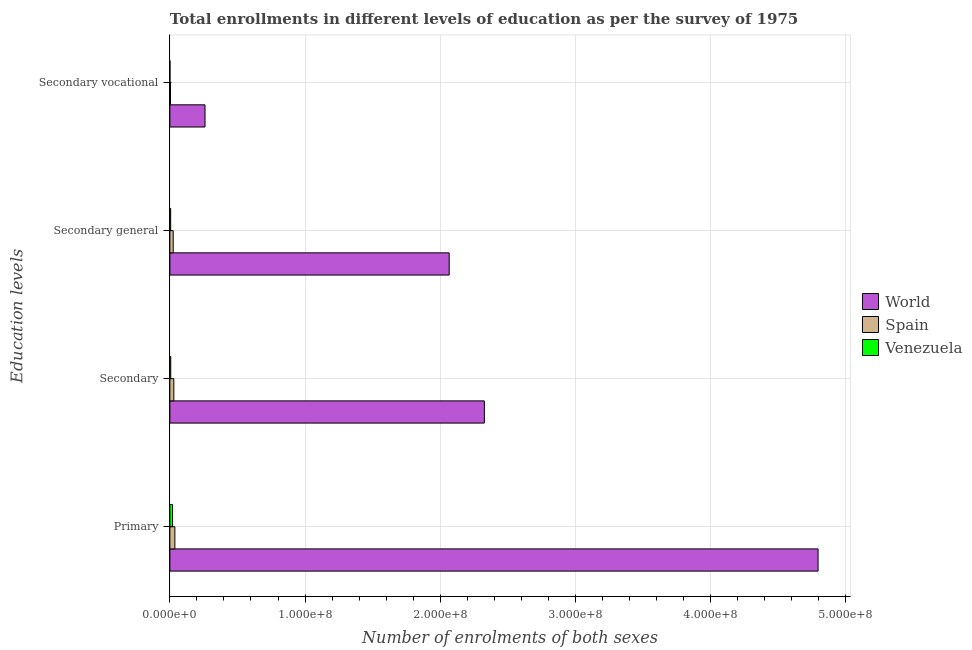How many different coloured bars are there?
Ensure brevity in your answer.  3. Are the number of bars per tick equal to the number of legend labels?
Keep it short and to the point. Yes. How many bars are there on the 3rd tick from the top?
Ensure brevity in your answer.  3. How many bars are there on the 1st tick from the bottom?
Provide a short and direct response. 3. What is the label of the 4th group of bars from the top?
Offer a very short reply. Primary. What is the number of enrolments in secondary general education in Venezuela?
Keep it short and to the point. 5.83e+05. Across all countries, what is the maximum number of enrolments in secondary vocational education?
Make the answer very short. 2.60e+07. Across all countries, what is the minimum number of enrolments in secondary education?
Offer a very short reply. 6.31e+05. In which country was the number of enrolments in primary education maximum?
Your answer should be very brief. World. In which country was the number of enrolments in secondary general education minimum?
Keep it short and to the point. Venezuela. What is the total number of enrolments in secondary vocational education in the graph?
Offer a very short reply. 2.65e+07. What is the difference between the number of enrolments in secondary vocational education in Venezuela and that in Spain?
Offer a terse response. -4.09e+05. What is the difference between the number of enrolments in secondary general education in Spain and the number of enrolments in secondary education in Venezuela?
Give a very brief answer. 1.83e+06. What is the average number of enrolments in secondary general education per country?
Provide a short and direct response. 6.99e+07. What is the difference between the number of enrolments in secondary vocational education and number of enrolments in secondary education in Spain?
Offer a terse response. -2.46e+06. What is the ratio of the number of enrolments in primary education in World to that in Spain?
Your answer should be very brief. 129.85. Is the difference between the number of enrolments in secondary education in Spain and Venezuela greater than the difference between the number of enrolments in secondary vocational education in Spain and Venezuela?
Provide a short and direct response. Yes. What is the difference between the highest and the second highest number of enrolments in primary education?
Provide a short and direct response. 4.76e+08. What is the difference between the highest and the lowest number of enrolments in secondary vocational education?
Make the answer very short. 2.59e+07. What does the 2nd bar from the top in Primary represents?
Keep it short and to the point. Spain. Is it the case that in every country, the sum of the number of enrolments in primary education and number of enrolments in secondary education is greater than the number of enrolments in secondary general education?
Your response must be concise. Yes. How many bars are there?
Ensure brevity in your answer.  12. Are all the bars in the graph horizontal?
Provide a succinct answer. Yes. Does the graph contain any zero values?
Provide a succinct answer. No. Does the graph contain grids?
Your answer should be very brief. Yes. Where does the legend appear in the graph?
Offer a terse response. Center right. How many legend labels are there?
Offer a very short reply. 3. What is the title of the graph?
Ensure brevity in your answer.  Total enrollments in different levels of education as per the survey of 1975. Does "Uzbekistan" appear as one of the legend labels in the graph?
Offer a terse response. No. What is the label or title of the X-axis?
Provide a succinct answer. Number of enrolments of both sexes. What is the label or title of the Y-axis?
Ensure brevity in your answer.  Education levels. What is the Number of enrolments of both sexes of World in Primary?
Make the answer very short. 4.79e+08. What is the Number of enrolments of both sexes in Spain in Primary?
Your answer should be compact. 3.69e+06. What is the Number of enrolments of both sexes of Venezuela in Primary?
Offer a very short reply. 1.99e+06. What is the Number of enrolments of both sexes of World in Secondary?
Offer a terse response. 2.33e+08. What is the Number of enrolments of both sexes in Spain in Secondary?
Provide a short and direct response. 2.92e+06. What is the Number of enrolments of both sexes of Venezuela in Secondary?
Your answer should be very brief. 6.31e+05. What is the Number of enrolments of both sexes in World in Secondary general?
Offer a very short reply. 2.07e+08. What is the Number of enrolments of both sexes in Spain in Secondary general?
Make the answer very short. 2.46e+06. What is the Number of enrolments of both sexes of Venezuela in Secondary general?
Your answer should be very brief. 5.83e+05. What is the Number of enrolments of both sexes of World in Secondary vocational?
Offer a very short reply. 2.60e+07. What is the Number of enrolments of both sexes in Spain in Secondary vocational?
Give a very brief answer. 4.57e+05. What is the Number of enrolments of both sexes of Venezuela in Secondary vocational?
Give a very brief answer. 4.80e+04. Across all Education levels, what is the maximum Number of enrolments of both sexes of World?
Give a very brief answer. 4.79e+08. Across all Education levels, what is the maximum Number of enrolments of both sexes of Spain?
Offer a very short reply. 3.69e+06. Across all Education levels, what is the maximum Number of enrolments of both sexes of Venezuela?
Give a very brief answer. 1.99e+06. Across all Education levels, what is the minimum Number of enrolments of both sexes of World?
Keep it short and to the point. 2.60e+07. Across all Education levels, what is the minimum Number of enrolments of both sexes of Spain?
Provide a short and direct response. 4.57e+05. Across all Education levels, what is the minimum Number of enrolments of both sexes of Venezuela?
Give a very brief answer. 4.80e+04. What is the total Number of enrolments of both sexes in World in the graph?
Offer a terse response. 9.45e+08. What is the total Number of enrolments of both sexes in Spain in the graph?
Your response must be concise. 9.53e+06. What is the total Number of enrolments of both sexes in Venezuela in the graph?
Make the answer very short. 3.25e+06. What is the difference between the Number of enrolments of both sexes in World in Primary and that in Secondary?
Give a very brief answer. 2.47e+08. What is the difference between the Number of enrolments of both sexes of Spain in Primary and that in Secondary?
Your answer should be very brief. 7.74e+05. What is the difference between the Number of enrolments of both sexes of Venezuela in Primary and that in Secondary?
Your response must be concise. 1.36e+06. What is the difference between the Number of enrolments of both sexes in World in Primary and that in Secondary general?
Give a very brief answer. 2.73e+08. What is the difference between the Number of enrolments of both sexes of Spain in Primary and that in Secondary general?
Offer a terse response. 1.23e+06. What is the difference between the Number of enrolments of both sexes of Venezuela in Primary and that in Secondary general?
Make the answer very short. 1.41e+06. What is the difference between the Number of enrolments of both sexes of World in Primary and that in Secondary vocational?
Give a very brief answer. 4.53e+08. What is the difference between the Number of enrolments of both sexes in Spain in Primary and that in Secondary vocational?
Keep it short and to the point. 3.24e+06. What is the difference between the Number of enrolments of both sexes of Venezuela in Primary and that in Secondary vocational?
Keep it short and to the point. 1.94e+06. What is the difference between the Number of enrolments of both sexes in World in Secondary and that in Secondary general?
Make the answer very short. 2.60e+07. What is the difference between the Number of enrolments of both sexes of Spain in Secondary and that in Secondary general?
Offer a very short reply. 4.57e+05. What is the difference between the Number of enrolments of both sexes of Venezuela in Secondary and that in Secondary general?
Keep it short and to the point. 4.80e+04. What is the difference between the Number of enrolments of both sexes of World in Secondary and that in Secondary vocational?
Offer a very short reply. 2.07e+08. What is the difference between the Number of enrolments of both sexes in Spain in Secondary and that in Secondary vocational?
Offer a very short reply. 2.46e+06. What is the difference between the Number of enrolments of both sexes in Venezuela in Secondary and that in Secondary vocational?
Your answer should be compact. 5.83e+05. What is the difference between the Number of enrolments of both sexes in World in Secondary general and that in Secondary vocational?
Your response must be concise. 1.81e+08. What is the difference between the Number of enrolments of both sexes in Spain in Secondary general and that in Secondary vocational?
Make the answer very short. 2.00e+06. What is the difference between the Number of enrolments of both sexes in Venezuela in Secondary general and that in Secondary vocational?
Offer a very short reply. 5.35e+05. What is the difference between the Number of enrolments of both sexes of World in Primary and the Number of enrolments of both sexes of Spain in Secondary?
Provide a succinct answer. 4.77e+08. What is the difference between the Number of enrolments of both sexes in World in Primary and the Number of enrolments of both sexes in Venezuela in Secondary?
Give a very brief answer. 4.79e+08. What is the difference between the Number of enrolments of both sexes of Spain in Primary and the Number of enrolments of both sexes of Venezuela in Secondary?
Make the answer very short. 3.06e+06. What is the difference between the Number of enrolments of both sexes of World in Primary and the Number of enrolments of both sexes of Spain in Secondary general?
Offer a terse response. 4.77e+08. What is the difference between the Number of enrolments of both sexes of World in Primary and the Number of enrolments of both sexes of Venezuela in Secondary general?
Ensure brevity in your answer.  4.79e+08. What is the difference between the Number of enrolments of both sexes of Spain in Primary and the Number of enrolments of both sexes of Venezuela in Secondary general?
Provide a short and direct response. 3.11e+06. What is the difference between the Number of enrolments of both sexes of World in Primary and the Number of enrolments of both sexes of Spain in Secondary vocational?
Provide a succinct answer. 4.79e+08. What is the difference between the Number of enrolments of both sexes in World in Primary and the Number of enrolments of both sexes in Venezuela in Secondary vocational?
Ensure brevity in your answer.  4.79e+08. What is the difference between the Number of enrolments of both sexes in Spain in Primary and the Number of enrolments of both sexes in Venezuela in Secondary vocational?
Provide a succinct answer. 3.64e+06. What is the difference between the Number of enrolments of both sexes of World in Secondary and the Number of enrolments of both sexes of Spain in Secondary general?
Offer a terse response. 2.30e+08. What is the difference between the Number of enrolments of both sexes of World in Secondary and the Number of enrolments of both sexes of Venezuela in Secondary general?
Offer a very short reply. 2.32e+08. What is the difference between the Number of enrolments of both sexes in Spain in Secondary and the Number of enrolments of both sexes in Venezuela in Secondary general?
Provide a succinct answer. 2.33e+06. What is the difference between the Number of enrolments of both sexes of World in Secondary and the Number of enrolments of both sexes of Spain in Secondary vocational?
Keep it short and to the point. 2.32e+08. What is the difference between the Number of enrolments of both sexes in World in Secondary and the Number of enrolments of both sexes in Venezuela in Secondary vocational?
Offer a terse response. 2.33e+08. What is the difference between the Number of enrolments of both sexes in Spain in Secondary and the Number of enrolments of both sexes in Venezuela in Secondary vocational?
Give a very brief answer. 2.87e+06. What is the difference between the Number of enrolments of both sexes in World in Secondary general and the Number of enrolments of both sexes in Spain in Secondary vocational?
Ensure brevity in your answer.  2.06e+08. What is the difference between the Number of enrolments of both sexes of World in Secondary general and the Number of enrolments of both sexes of Venezuela in Secondary vocational?
Offer a terse response. 2.07e+08. What is the difference between the Number of enrolments of both sexes of Spain in Secondary general and the Number of enrolments of both sexes of Venezuela in Secondary vocational?
Provide a short and direct response. 2.41e+06. What is the average Number of enrolments of both sexes of World per Education levels?
Offer a terse response. 2.36e+08. What is the average Number of enrolments of both sexes of Spain per Education levels?
Make the answer very short. 2.38e+06. What is the average Number of enrolments of both sexes in Venezuela per Education levels?
Keep it short and to the point. 8.13e+05. What is the difference between the Number of enrolments of both sexes in World and Number of enrolments of both sexes in Spain in Primary?
Provide a short and direct response. 4.76e+08. What is the difference between the Number of enrolments of both sexes in World and Number of enrolments of both sexes in Venezuela in Primary?
Give a very brief answer. 4.77e+08. What is the difference between the Number of enrolments of both sexes in Spain and Number of enrolments of both sexes in Venezuela in Primary?
Keep it short and to the point. 1.70e+06. What is the difference between the Number of enrolments of both sexes in World and Number of enrolments of both sexes in Spain in Secondary?
Your response must be concise. 2.30e+08. What is the difference between the Number of enrolments of both sexes of World and Number of enrolments of both sexes of Venezuela in Secondary?
Keep it short and to the point. 2.32e+08. What is the difference between the Number of enrolments of both sexes of Spain and Number of enrolments of both sexes of Venezuela in Secondary?
Your answer should be very brief. 2.29e+06. What is the difference between the Number of enrolments of both sexes of World and Number of enrolments of both sexes of Spain in Secondary general?
Your answer should be compact. 2.04e+08. What is the difference between the Number of enrolments of both sexes in World and Number of enrolments of both sexes in Venezuela in Secondary general?
Your answer should be compact. 2.06e+08. What is the difference between the Number of enrolments of both sexes of Spain and Number of enrolments of both sexes of Venezuela in Secondary general?
Make the answer very short. 1.88e+06. What is the difference between the Number of enrolments of both sexes of World and Number of enrolments of both sexes of Spain in Secondary vocational?
Provide a succinct answer. 2.55e+07. What is the difference between the Number of enrolments of both sexes in World and Number of enrolments of both sexes in Venezuela in Secondary vocational?
Offer a terse response. 2.59e+07. What is the difference between the Number of enrolments of both sexes in Spain and Number of enrolments of both sexes in Venezuela in Secondary vocational?
Your answer should be compact. 4.09e+05. What is the ratio of the Number of enrolments of both sexes of World in Primary to that in Secondary?
Your answer should be compact. 2.06. What is the ratio of the Number of enrolments of both sexes of Spain in Primary to that in Secondary?
Your answer should be compact. 1.27. What is the ratio of the Number of enrolments of both sexes in Venezuela in Primary to that in Secondary?
Keep it short and to the point. 3.15. What is the ratio of the Number of enrolments of both sexes of World in Primary to that in Secondary general?
Your response must be concise. 2.32. What is the ratio of the Number of enrolments of both sexes in Spain in Primary to that in Secondary general?
Provide a short and direct response. 1.5. What is the ratio of the Number of enrolments of both sexes of Venezuela in Primary to that in Secondary general?
Provide a short and direct response. 3.41. What is the ratio of the Number of enrolments of both sexes of World in Primary to that in Secondary vocational?
Your answer should be compact. 18.44. What is the ratio of the Number of enrolments of both sexes of Spain in Primary to that in Secondary vocational?
Offer a terse response. 8.08. What is the ratio of the Number of enrolments of both sexes of Venezuela in Primary to that in Secondary vocational?
Provide a succinct answer. 41.42. What is the ratio of the Number of enrolments of both sexes of World in Secondary to that in Secondary general?
Your answer should be very brief. 1.13. What is the ratio of the Number of enrolments of both sexes of Spain in Secondary to that in Secondary general?
Provide a short and direct response. 1.19. What is the ratio of the Number of enrolments of both sexes in Venezuela in Secondary to that in Secondary general?
Provide a succinct answer. 1.08. What is the ratio of the Number of enrolments of both sexes in World in Secondary to that in Secondary vocational?
Keep it short and to the point. 8.95. What is the ratio of the Number of enrolments of both sexes of Spain in Secondary to that in Secondary vocational?
Provide a short and direct response. 6.39. What is the ratio of the Number of enrolments of both sexes in Venezuela in Secondary to that in Secondary vocational?
Provide a succinct answer. 13.14. What is the ratio of the Number of enrolments of both sexes of World in Secondary general to that in Secondary vocational?
Keep it short and to the point. 7.95. What is the ratio of the Number of enrolments of both sexes in Spain in Secondary general to that in Secondary vocational?
Offer a terse response. 5.39. What is the ratio of the Number of enrolments of both sexes of Venezuela in Secondary general to that in Secondary vocational?
Offer a terse response. 12.14. What is the difference between the highest and the second highest Number of enrolments of both sexes in World?
Your answer should be very brief. 2.47e+08. What is the difference between the highest and the second highest Number of enrolments of both sexes of Spain?
Your response must be concise. 7.74e+05. What is the difference between the highest and the second highest Number of enrolments of both sexes of Venezuela?
Keep it short and to the point. 1.36e+06. What is the difference between the highest and the lowest Number of enrolments of both sexes in World?
Your response must be concise. 4.53e+08. What is the difference between the highest and the lowest Number of enrolments of both sexes of Spain?
Offer a very short reply. 3.24e+06. What is the difference between the highest and the lowest Number of enrolments of both sexes in Venezuela?
Offer a very short reply. 1.94e+06. 